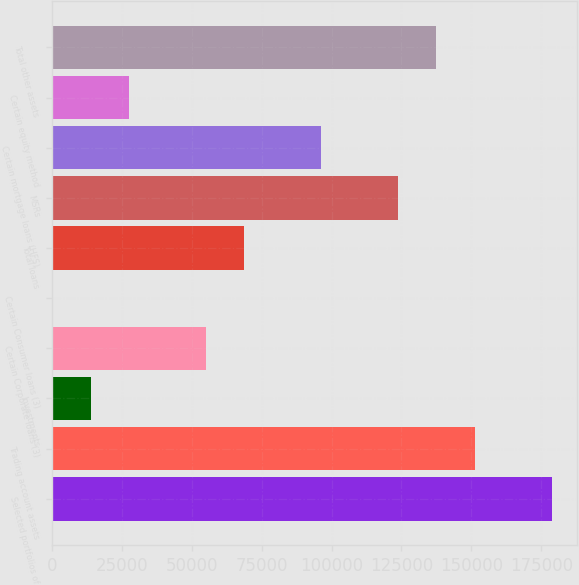Convert chart to OTSL. <chart><loc_0><loc_0><loc_500><loc_500><bar_chart><fcel>Selected portfolios of<fcel>Trading account assets<fcel>Investments<fcel>Certain Corporate loans (3)<fcel>Certain Consumer loans (3)<fcel>Total loans<fcel>MSRs<fcel>Certain mortgage loans (HFS)<fcel>Certain equity method<fcel>Total other assets<nl><fcel>178715<fcel>151226<fcel>13778.7<fcel>55012.8<fcel>34<fcel>68757.5<fcel>123736<fcel>96246.9<fcel>27523.4<fcel>137481<nl></chart> 